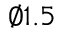Convert formula to latex. <formula><loc_0><loc_0><loc_500><loc_500>\varnothing 1 . 5</formula> 